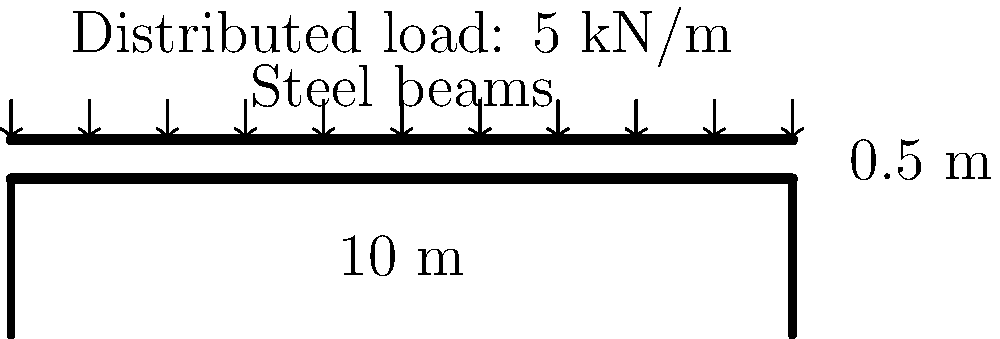As a runway model, you're concerned about the safety of the catwalk you'll be walking on. The catwalk is 10 meters long, 0.5 meters wide, and supported by steel beams at both ends. It's designed to withstand a uniformly distributed load of 5 kN/m. What is the maximum bending moment experienced by the catwalk structure? To find the maximum bending moment for a simply supported beam with a uniformly distributed load, we can follow these steps:

1. Identify the given information:
   - Length of catwalk (L) = 10 m
   - Uniformly distributed load (w) = 5 kN/m

2. For a simply supported beam with a uniformly distributed load, the maximum bending moment occurs at the center of the beam and is given by the formula:

   $M_{max} = \frac{wL^2}{8}$

3. Substitute the values into the formula:
   $M_{max} = \frac{5 \text{ kN/m} \times (10 \text{ m})^2}{8}$

4. Calculate:
   $M_{max} = \frac{5 \times 100}{8} = \frac{500}{8} = 62.5 \text{ kN}\cdot\text{m}$

Therefore, the maximum bending moment experienced by the catwalk structure is 62.5 kN·m.
Answer: 62.5 kN·m 